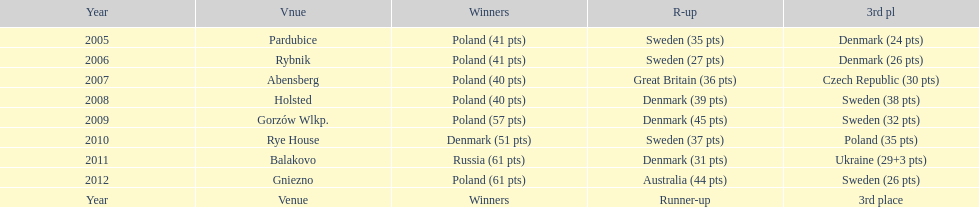Which team has the most third place wins in the speedway junior world championship between 2005 and 2012? Sweden. 